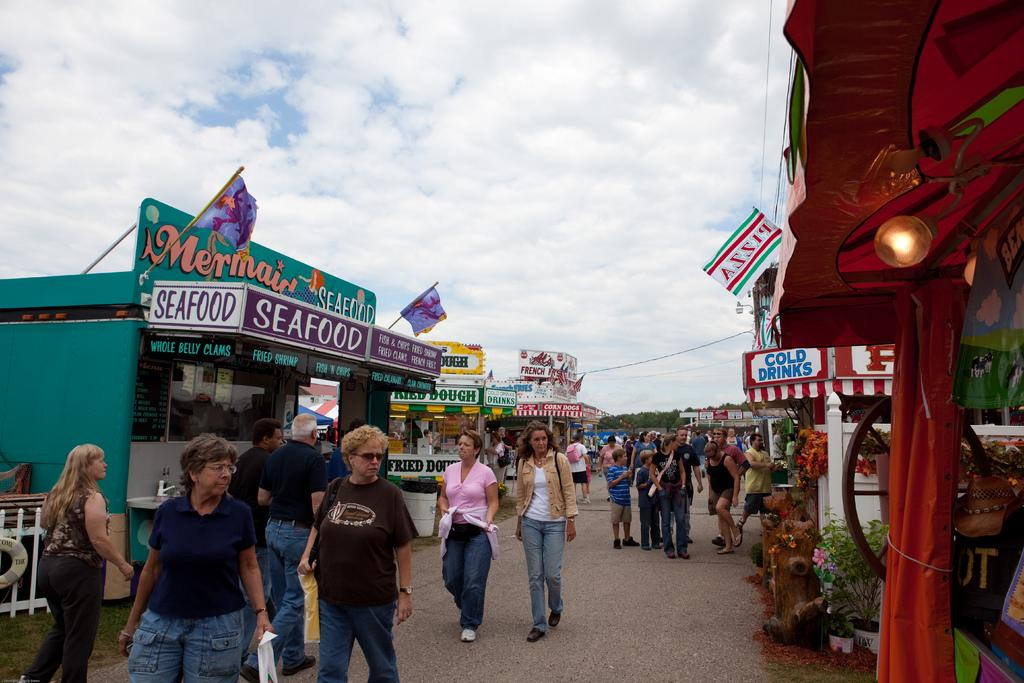What type of structures can be seen in the image? There are buildings in the image. What is hanging or attached in the image? There is a banner in the image. What can be seen illuminating the scene in the image? There are lights in the image. What type of vegetation is present in the image? There are plants in the image. Who or what is present in the image? There are people in the image. What is visible at the top of the image? The sky is visible at the top of the image. What can be seen in the sky in the image? There are clouds in the sky. What type of pencil can be seen in the image? There is no pencil present in the image. What is the need for the tent in the image? There is no tent present in the image. 